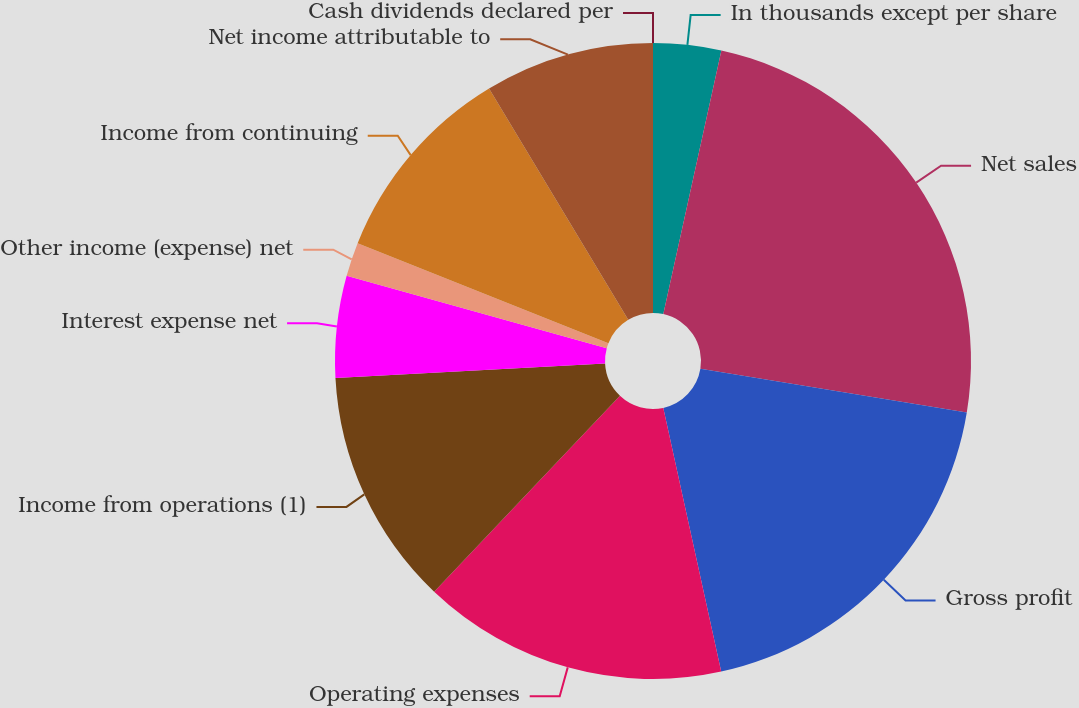Convert chart. <chart><loc_0><loc_0><loc_500><loc_500><pie_chart><fcel>In thousands except per share<fcel>Net sales<fcel>Gross profit<fcel>Operating expenses<fcel>Income from operations (1)<fcel>Interest expense net<fcel>Other income (expense) net<fcel>Income from continuing<fcel>Net income attributable to<fcel>Cash dividends declared per<nl><fcel>3.45%<fcel>24.14%<fcel>18.97%<fcel>15.52%<fcel>12.07%<fcel>5.17%<fcel>1.72%<fcel>10.34%<fcel>8.62%<fcel>0.0%<nl></chart> 